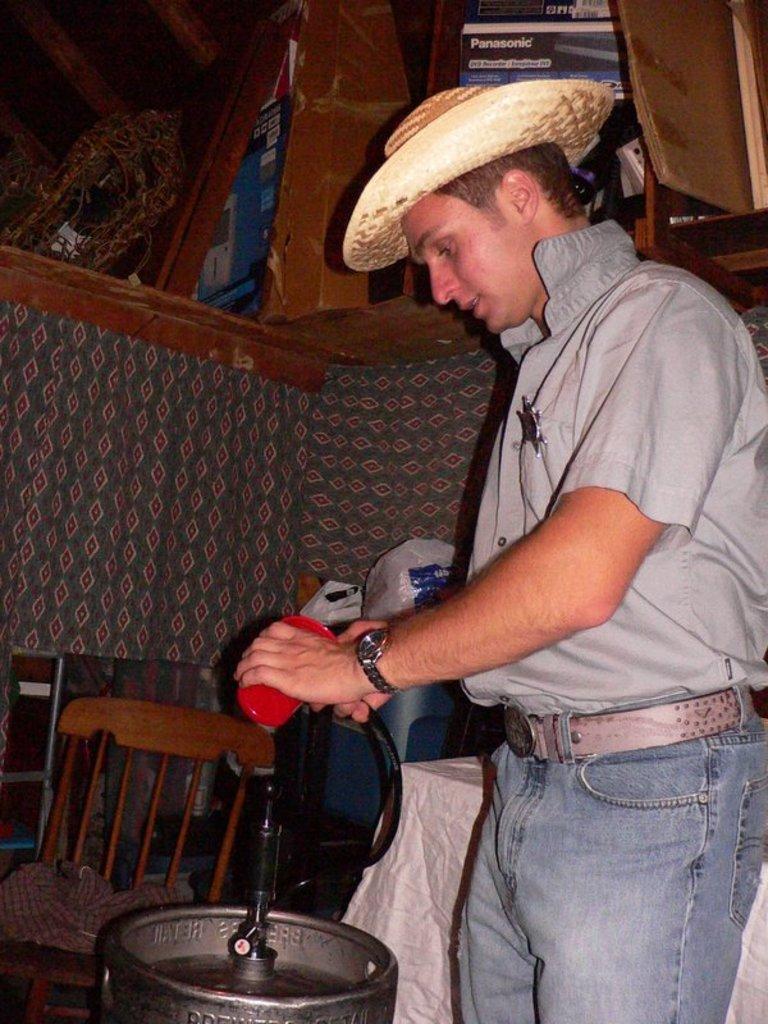Could you give a brief overview of what you see in this image? In this image there is a man standing. He is wearing a grey shirt and a hat. There is a chair beside him. In front of him there is an instrument. 